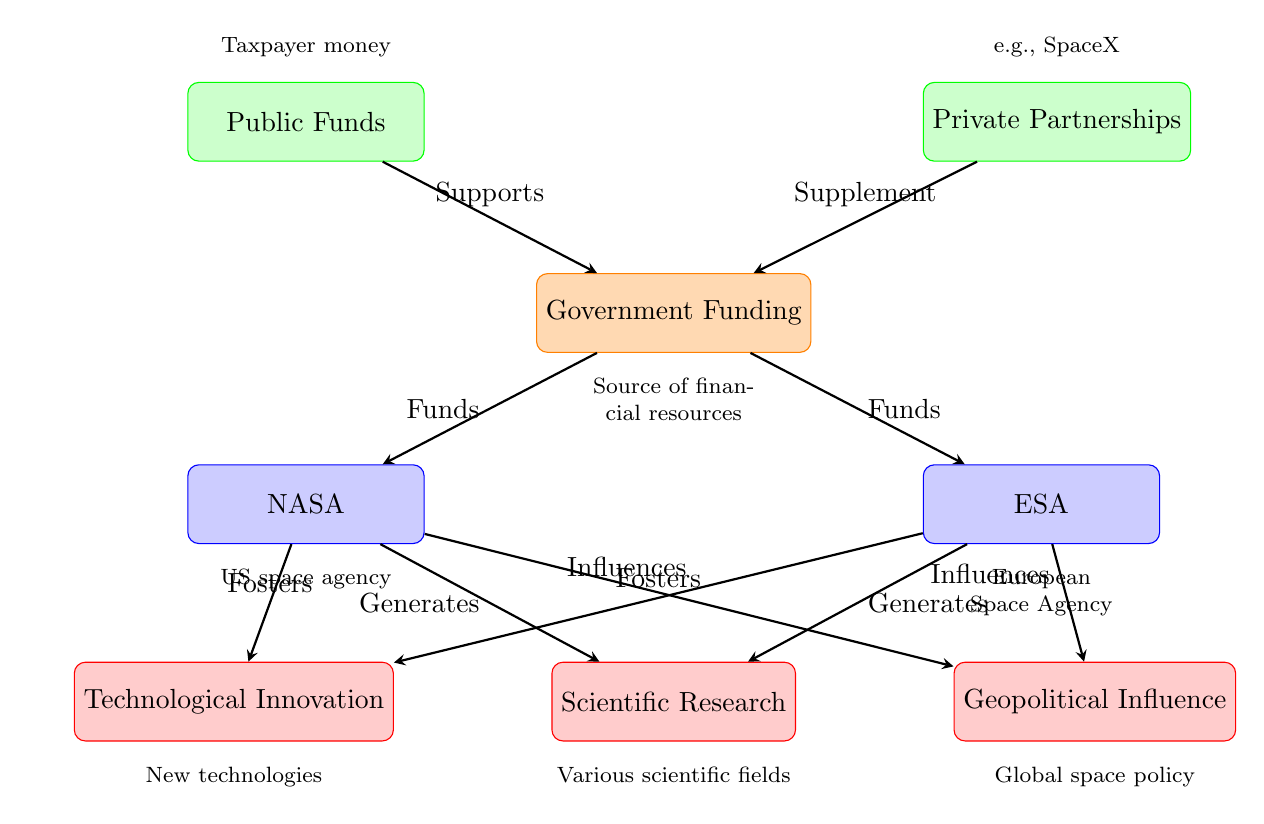What are the two sources of government funding? The diagram lists "Public Funds" and "Private Partnerships" as the two sources contributing to government funding for space exploration.
Answer: Public Funds, Private Partnerships Which agency receives funds from the government? According to the diagram, both NASA and ESA receive funds from the government as indicated by the arrows pointing from "Government Funding" to these agencies.
Answer: NASA, ESA What output is generated by NASA? The diagram shows that NASA generates "Scientific Research," as indicated by the arrow flowing from NASA to the output labeled "Scientific Research."
Answer: Scientific Research How many nodes are labeled as outputs? There are three nodes that are labeled as outputs in the diagram: "Scientific Research," "Technological Innovation," and "Geopolitical Influence." This is determined by counting the bottom nodes that show outcomes of funding.
Answer: Three What method does the public use to support government funding? The diagram indicates that the public supports government funding through "Taxpayer money," as indicated by the label above the "Public Funds" node.
Answer: Taxpayer money Which agency influences geopolitical dynamics? Both NASA and ESA influence geopolitical dynamics, as shown by the arrows pointing from each agency to the output labeled "Geopolitical Influence." Thus, both agencies are responsible for this influence.
Answer: NASA, ESA What role do private partnerships play in funding? The diagram describes private partnerships as "Supplement" to government funding, which shows that they provide additional financial resources to the government funding system.
Answer: Supplement How does NASA foster technological developments? The 'Fosters' arrow from NASA points to the output labeled "Technological Innovation," indicating that NASA is involved in developing new technologies as a result of its operations.
Answer: Fosters What type of agency is NASA described as? The diagram describes NASA as the "US space agency," which is explicitly noted in the label below the NASA node.
Answer: US space agency 